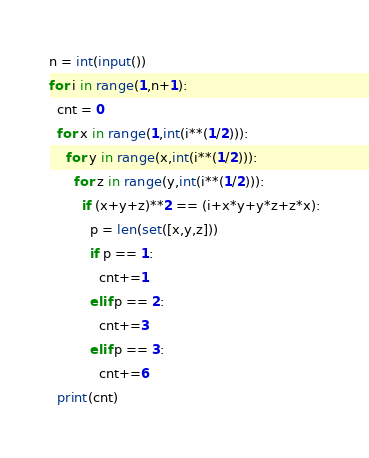<code> <loc_0><loc_0><loc_500><loc_500><_Python_>n = int(input())
for i in range(1,n+1):
  cnt = 0
  for x in range(1,int(i**(1/2))):
    for y in range(x,int(i**(1/2))):
      for z in range(y,int(i**(1/2))):
        if (x+y+z)**2 == (i+x*y+y*z+z*x):
          p = len(set([x,y,z]))
          if p == 1:
            cnt+=1
          elif p == 2:
            cnt+=3
          elif p == 3:
            cnt+=6
  print(cnt)</code> 